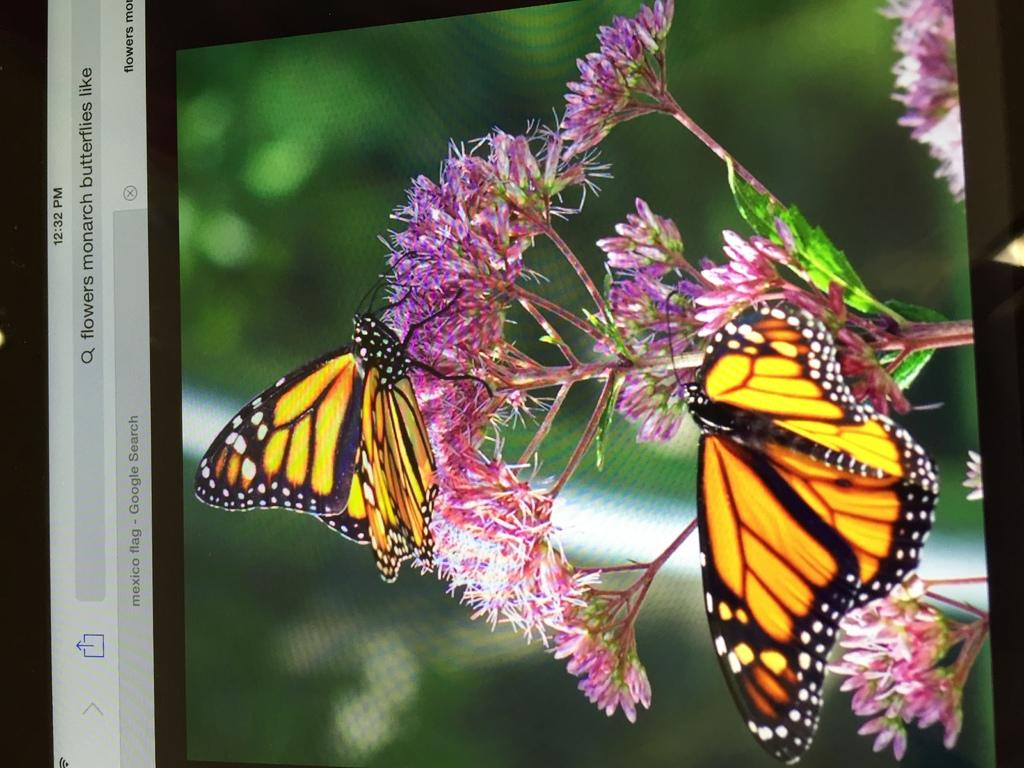What is the main subject of the image? There is a screen in the image. What can be seen on the screen? The screen contains a plant, butterflies, and flowers. How would you describe the background of the image? The background of the image is blurred. Where is the jar of flowers located in the image? There is no jar of flowers present in the image. What type of station is visible in the image? There is no station visible in the image. 